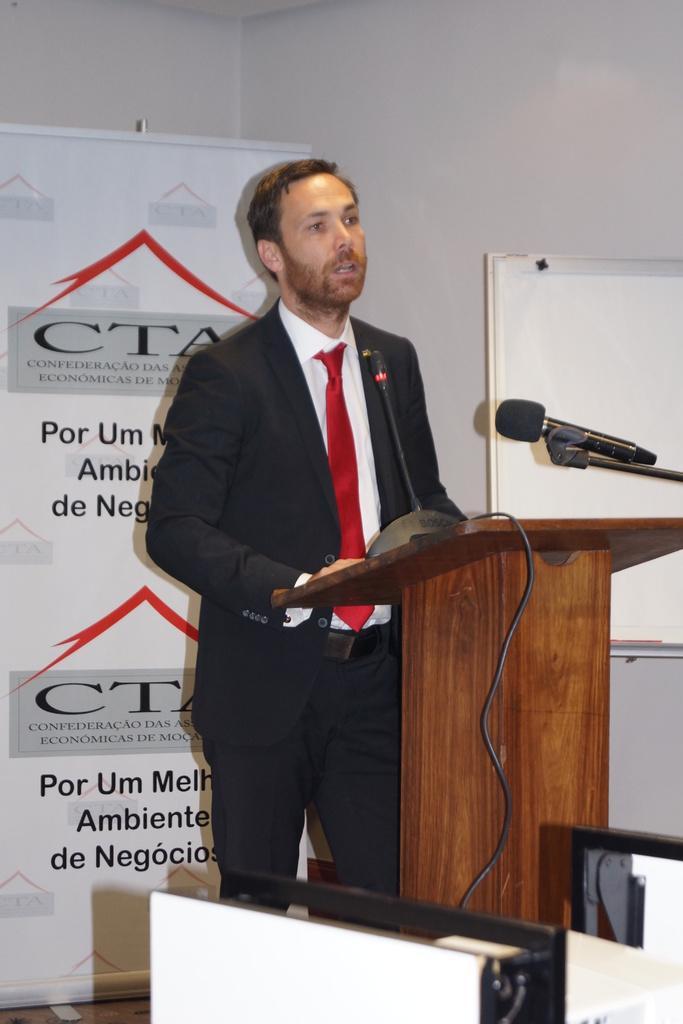In one or two sentences, can you explain what this image depicts? In the center of the image we can see one person is standing. In front of him, we can see one wooden stand, microphone, wire, white color objects and a few other objects. In the background there is a wallboard, banner and a few other objects. On the banner, we can see some text. 